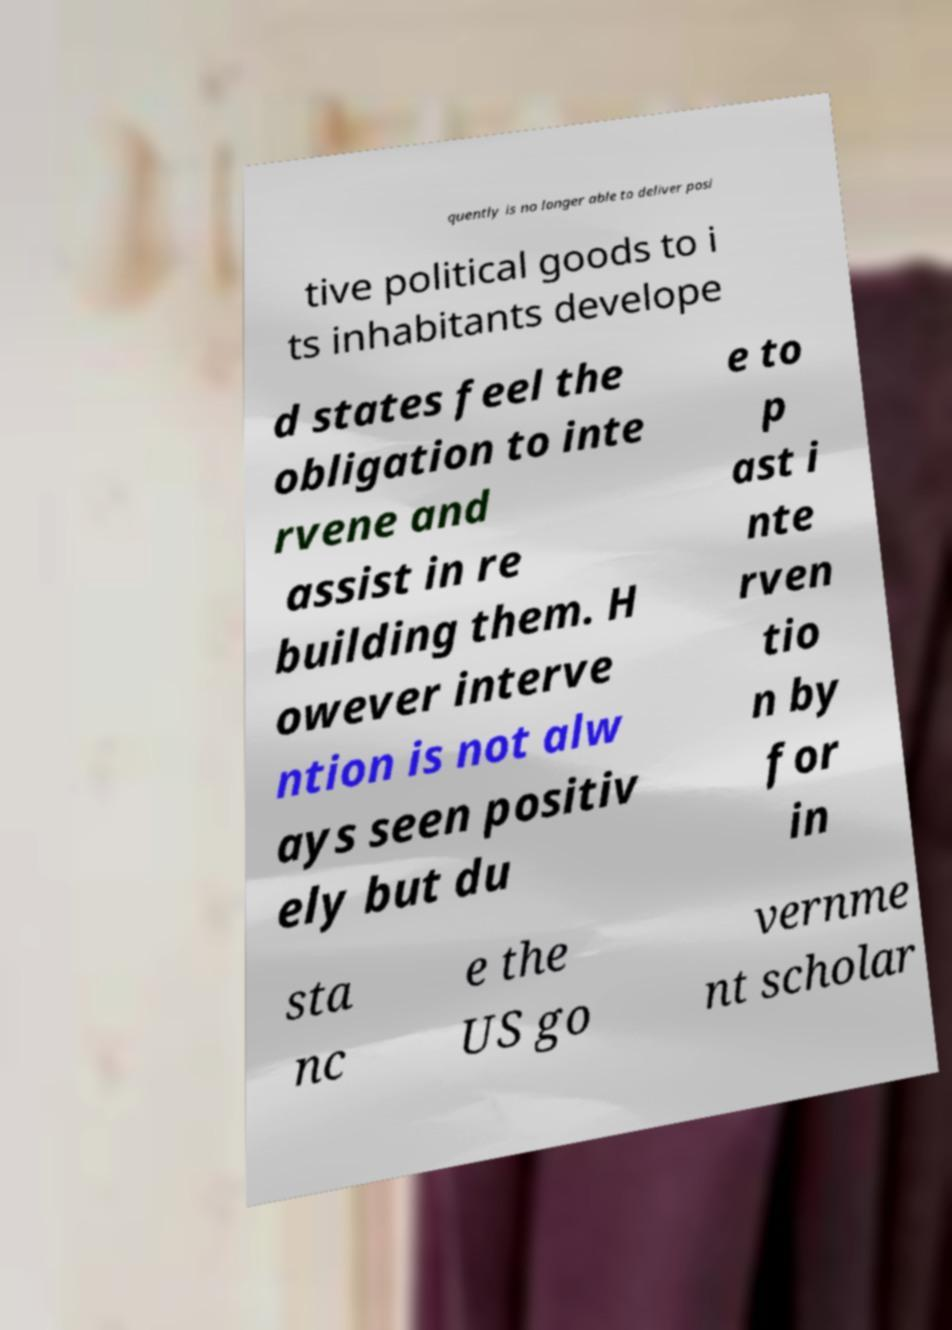Please identify and transcribe the text found in this image. quently is no longer able to deliver posi tive political goods to i ts inhabitants develope d states feel the obligation to inte rvene and assist in re building them. H owever interve ntion is not alw ays seen positiv ely but du e to p ast i nte rven tio n by for in sta nc e the US go vernme nt scholar 